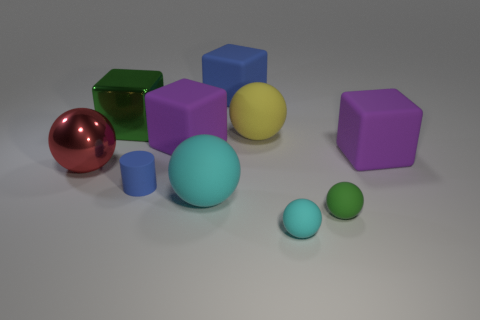Subtract all red balls. How many balls are left? 4 Subtract all gray spheres. Subtract all cyan cubes. How many spheres are left? 5 Subtract all cylinders. How many objects are left? 9 Add 10 small purple metallic things. How many small purple metallic things exist? 10 Subtract 0 yellow cylinders. How many objects are left? 10 Subtract all large spheres. Subtract all cubes. How many objects are left? 3 Add 4 large rubber things. How many large rubber things are left? 9 